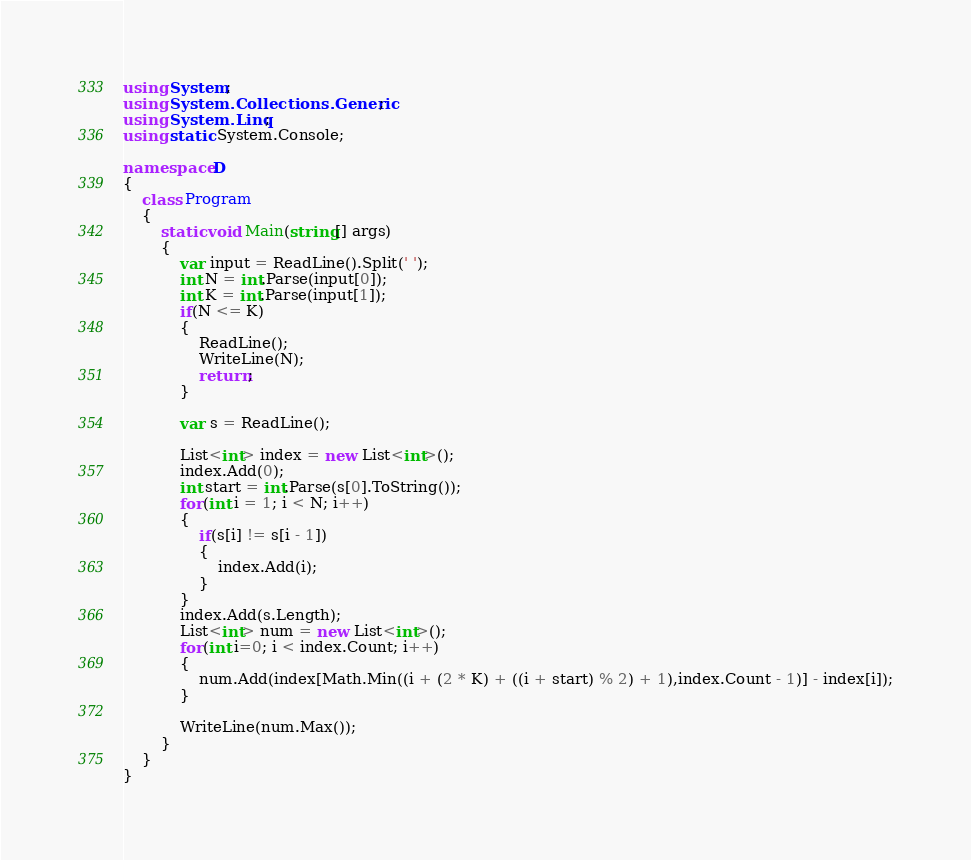Convert code to text. <code><loc_0><loc_0><loc_500><loc_500><_C#_>using System;
using System.Collections.Generic;
using System.Linq;
using static System.Console;

namespace D
{
    class Program
    {
        static void Main(string[] args)
        {
            var input = ReadLine().Split(' ');
            int N = int.Parse(input[0]);
            int K = int.Parse(input[1]);
            if(N <= K)
            {
                ReadLine();
                WriteLine(N);
                return;
            }

            var s = ReadLine();

            List<int> index = new List<int>();
            index.Add(0);
            int start = int.Parse(s[0].ToString());
            for(int i = 1; i < N; i++)
            {
                if(s[i] != s[i - 1])
                {
                    index.Add(i);
                }
            }
            index.Add(s.Length);
            List<int> num = new List<int>();
            for(int i=0; i < index.Count; i++)
            {
                num.Add(index[Math.Min((i + (2 * K) + ((i + start) % 2) + 1),index.Count - 1)] - index[i]);
            }

            WriteLine(num.Max());
        }
    }
}
</code> 